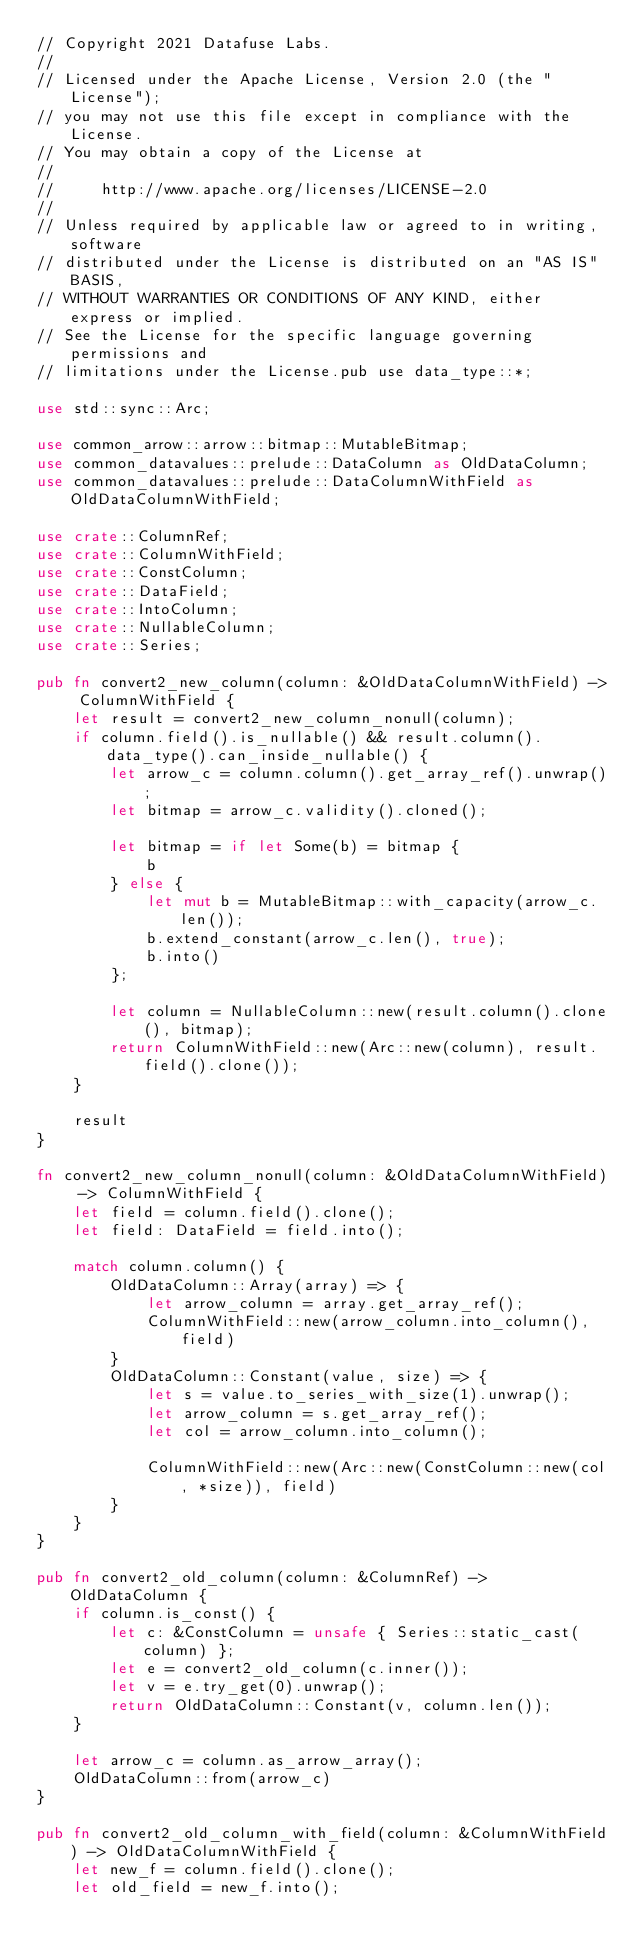<code> <loc_0><loc_0><loc_500><loc_500><_Rust_>// Copyright 2021 Datafuse Labs.
//
// Licensed under the Apache License, Version 2.0 (the "License");
// you may not use this file except in compliance with the License.
// You may obtain a copy of the License at
//
//     http://www.apache.org/licenses/LICENSE-2.0
//
// Unless required by applicable law or agreed to in writing, software
// distributed under the License is distributed on an "AS IS" BASIS,
// WITHOUT WARRANTIES OR CONDITIONS OF ANY KIND, either express or implied.
// See the License for the specific language governing permissions and
// limitations under the License.pub use data_type::*;

use std::sync::Arc;

use common_arrow::arrow::bitmap::MutableBitmap;
use common_datavalues::prelude::DataColumn as OldDataColumn;
use common_datavalues::prelude::DataColumnWithField as OldDataColumnWithField;

use crate::ColumnRef;
use crate::ColumnWithField;
use crate::ConstColumn;
use crate::DataField;
use crate::IntoColumn;
use crate::NullableColumn;
use crate::Series;

pub fn convert2_new_column(column: &OldDataColumnWithField) -> ColumnWithField {
    let result = convert2_new_column_nonull(column);
    if column.field().is_nullable() && result.column().data_type().can_inside_nullable() {
        let arrow_c = column.column().get_array_ref().unwrap();
        let bitmap = arrow_c.validity().cloned();

        let bitmap = if let Some(b) = bitmap {
            b
        } else {
            let mut b = MutableBitmap::with_capacity(arrow_c.len());
            b.extend_constant(arrow_c.len(), true);
            b.into()
        };

        let column = NullableColumn::new(result.column().clone(), bitmap);
        return ColumnWithField::new(Arc::new(column), result.field().clone());
    }

    result
}

fn convert2_new_column_nonull(column: &OldDataColumnWithField) -> ColumnWithField {
    let field = column.field().clone();
    let field: DataField = field.into();

    match column.column() {
        OldDataColumn::Array(array) => {
            let arrow_column = array.get_array_ref();
            ColumnWithField::new(arrow_column.into_column(), field)
        }
        OldDataColumn::Constant(value, size) => {
            let s = value.to_series_with_size(1).unwrap();
            let arrow_column = s.get_array_ref();
            let col = arrow_column.into_column();

            ColumnWithField::new(Arc::new(ConstColumn::new(col, *size)), field)
        }
    }
}

pub fn convert2_old_column(column: &ColumnRef) -> OldDataColumn {
    if column.is_const() {
        let c: &ConstColumn = unsafe { Series::static_cast(column) };
        let e = convert2_old_column(c.inner());
        let v = e.try_get(0).unwrap();
        return OldDataColumn::Constant(v, column.len());
    }

    let arrow_c = column.as_arrow_array();
    OldDataColumn::from(arrow_c)
}

pub fn convert2_old_column_with_field(column: &ColumnWithField) -> OldDataColumnWithField {
    let new_f = column.field().clone();
    let old_field = new_f.into();
</code> 